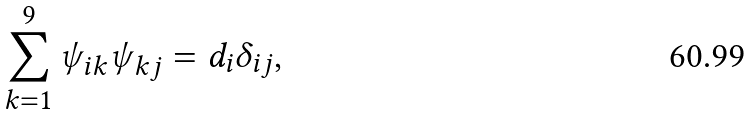Convert formula to latex. <formula><loc_0><loc_0><loc_500><loc_500>\sum _ { k = 1 } ^ { 9 } \psi _ { i k } \psi _ { k j } = d _ { i } \delta _ { i j } ,</formula> 